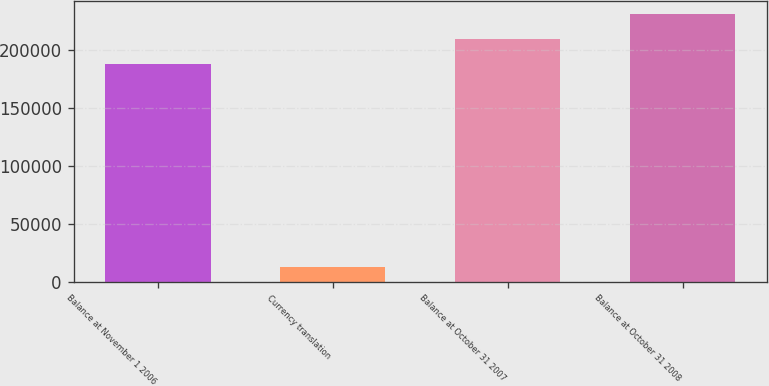Convert chart to OTSL. <chart><loc_0><loc_0><loc_500><loc_500><bar_chart><fcel>Balance at November 1 2006<fcel>Currency translation<fcel>Balance at October 31 2007<fcel>Balance at October 31 2008<nl><fcel>187681<fcel>12850<fcel>209477<fcel>231273<nl></chart> 